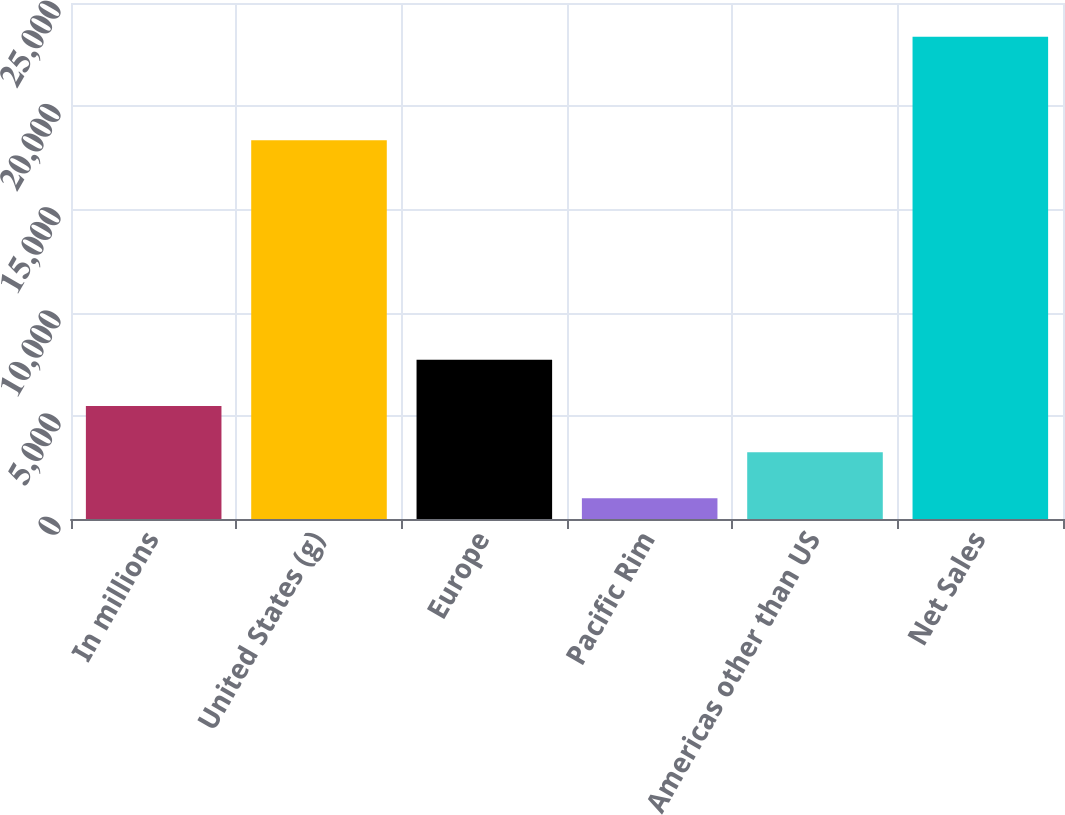Convert chart. <chart><loc_0><loc_0><loc_500><loc_500><bar_chart><fcel>In millions<fcel>United States (g)<fcel>Europe<fcel>Pacific Rim<fcel>Americas other than US<fcel>Net Sales<nl><fcel>5474.8<fcel>18355<fcel>7711.2<fcel>1002<fcel>3238.4<fcel>23366<nl></chart> 